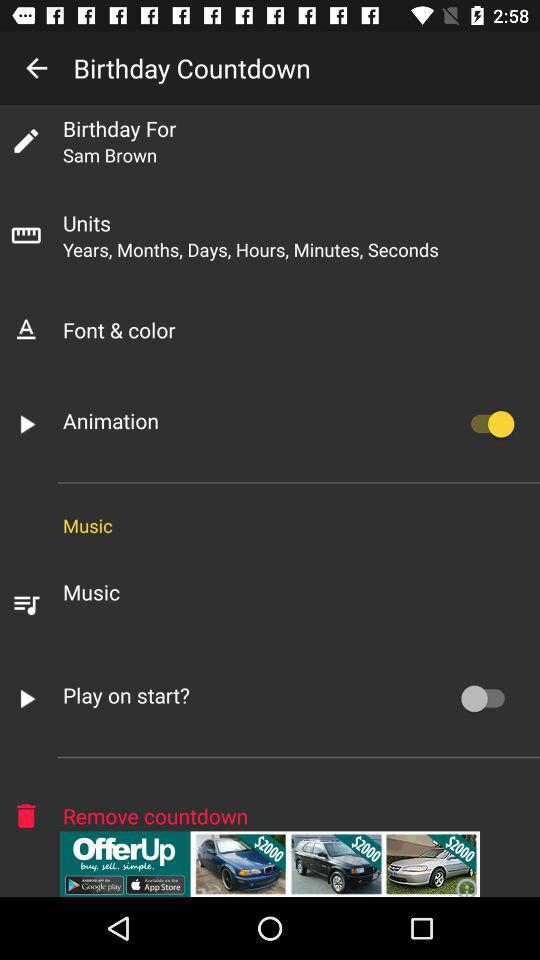What is the status of "Play on start?"? The status of "Play on start?" is "off". 